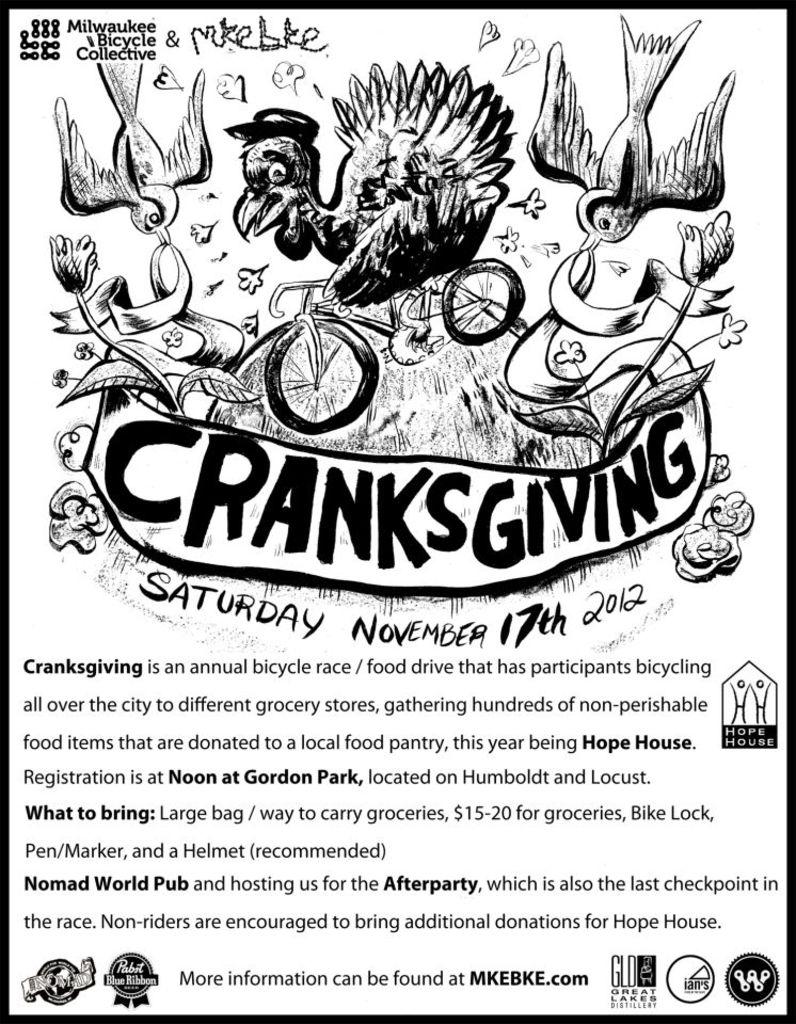Are you able to read the article?
Ensure brevity in your answer.  Yes. What is the date on this article?
Provide a succinct answer. November 17th 2012. 